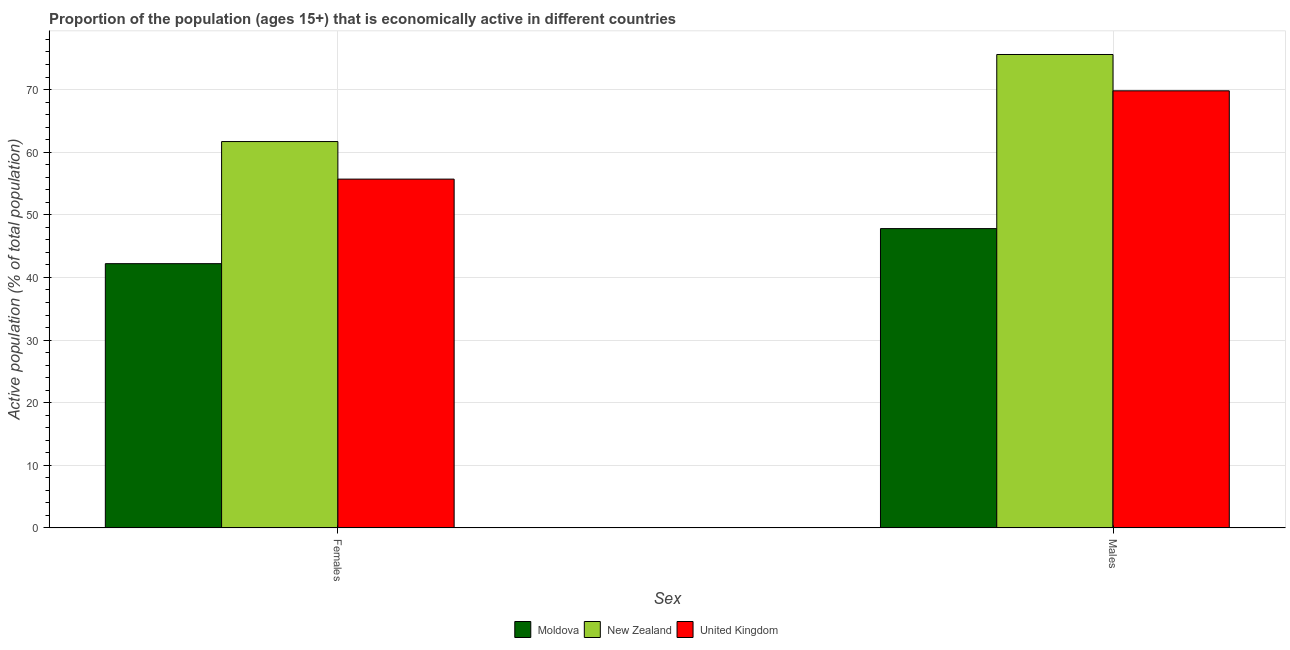How many bars are there on the 2nd tick from the right?
Make the answer very short. 3. What is the label of the 2nd group of bars from the left?
Your answer should be very brief. Males. What is the percentage of economically active male population in New Zealand?
Give a very brief answer. 75.6. Across all countries, what is the maximum percentage of economically active male population?
Provide a short and direct response. 75.6. Across all countries, what is the minimum percentage of economically active male population?
Your response must be concise. 47.8. In which country was the percentage of economically active female population maximum?
Provide a short and direct response. New Zealand. In which country was the percentage of economically active female population minimum?
Provide a short and direct response. Moldova. What is the total percentage of economically active male population in the graph?
Make the answer very short. 193.2. What is the difference between the percentage of economically active male population in New Zealand and that in Moldova?
Provide a succinct answer. 27.8. What is the difference between the percentage of economically active male population in New Zealand and the percentage of economically active female population in United Kingdom?
Keep it short and to the point. 19.9. What is the average percentage of economically active female population per country?
Offer a very short reply. 53.2. What is the difference between the percentage of economically active male population and percentage of economically active female population in New Zealand?
Your answer should be compact. 13.9. What is the ratio of the percentage of economically active female population in New Zealand to that in United Kingdom?
Provide a short and direct response. 1.11. Is the percentage of economically active female population in Moldova less than that in United Kingdom?
Your answer should be very brief. Yes. In how many countries, is the percentage of economically active male population greater than the average percentage of economically active male population taken over all countries?
Ensure brevity in your answer.  2. What does the 2nd bar from the right in Females represents?
Keep it short and to the point. New Zealand. How many countries are there in the graph?
Make the answer very short. 3. What is the difference between two consecutive major ticks on the Y-axis?
Offer a very short reply. 10. Does the graph contain any zero values?
Offer a very short reply. No. Does the graph contain grids?
Make the answer very short. Yes. How are the legend labels stacked?
Your answer should be very brief. Horizontal. What is the title of the graph?
Ensure brevity in your answer.  Proportion of the population (ages 15+) that is economically active in different countries. Does "Bolivia" appear as one of the legend labels in the graph?
Your answer should be compact. No. What is the label or title of the X-axis?
Offer a terse response. Sex. What is the label or title of the Y-axis?
Offer a terse response. Active population (% of total population). What is the Active population (% of total population) of Moldova in Females?
Keep it short and to the point. 42.2. What is the Active population (% of total population) of New Zealand in Females?
Give a very brief answer. 61.7. What is the Active population (% of total population) in United Kingdom in Females?
Ensure brevity in your answer.  55.7. What is the Active population (% of total population) in Moldova in Males?
Ensure brevity in your answer.  47.8. What is the Active population (% of total population) in New Zealand in Males?
Make the answer very short. 75.6. What is the Active population (% of total population) in United Kingdom in Males?
Your answer should be very brief. 69.8. Across all Sex, what is the maximum Active population (% of total population) in Moldova?
Give a very brief answer. 47.8. Across all Sex, what is the maximum Active population (% of total population) of New Zealand?
Ensure brevity in your answer.  75.6. Across all Sex, what is the maximum Active population (% of total population) in United Kingdom?
Offer a terse response. 69.8. Across all Sex, what is the minimum Active population (% of total population) in Moldova?
Ensure brevity in your answer.  42.2. Across all Sex, what is the minimum Active population (% of total population) of New Zealand?
Your response must be concise. 61.7. Across all Sex, what is the minimum Active population (% of total population) of United Kingdom?
Ensure brevity in your answer.  55.7. What is the total Active population (% of total population) in Moldova in the graph?
Your answer should be very brief. 90. What is the total Active population (% of total population) of New Zealand in the graph?
Your answer should be very brief. 137.3. What is the total Active population (% of total population) of United Kingdom in the graph?
Provide a short and direct response. 125.5. What is the difference between the Active population (% of total population) of United Kingdom in Females and that in Males?
Make the answer very short. -14.1. What is the difference between the Active population (% of total population) of Moldova in Females and the Active population (% of total population) of New Zealand in Males?
Your answer should be compact. -33.4. What is the difference between the Active population (% of total population) of Moldova in Females and the Active population (% of total population) of United Kingdom in Males?
Make the answer very short. -27.6. What is the average Active population (% of total population) in Moldova per Sex?
Provide a succinct answer. 45. What is the average Active population (% of total population) of New Zealand per Sex?
Offer a very short reply. 68.65. What is the average Active population (% of total population) in United Kingdom per Sex?
Make the answer very short. 62.75. What is the difference between the Active population (% of total population) in Moldova and Active population (% of total population) in New Zealand in Females?
Your answer should be very brief. -19.5. What is the difference between the Active population (% of total population) in Moldova and Active population (% of total population) in United Kingdom in Females?
Offer a terse response. -13.5. What is the difference between the Active population (% of total population) in New Zealand and Active population (% of total population) in United Kingdom in Females?
Your answer should be very brief. 6. What is the difference between the Active population (% of total population) of Moldova and Active population (% of total population) of New Zealand in Males?
Provide a succinct answer. -27.8. What is the difference between the Active population (% of total population) of Moldova and Active population (% of total population) of United Kingdom in Males?
Give a very brief answer. -22. What is the difference between the Active population (% of total population) of New Zealand and Active population (% of total population) of United Kingdom in Males?
Your response must be concise. 5.8. What is the ratio of the Active population (% of total population) in Moldova in Females to that in Males?
Provide a short and direct response. 0.88. What is the ratio of the Active population (% of total population) in New Zealand in Females to that in Males?
Your answer should be compact. 0.82. What is the ratio of the Active population (% of total population) of United Kingdom in Females to that in Males?
Your response must be concise. 0.8. What is the difference between the highest and the second highest Active population (% of total population) in Moldova?
Give a very brief answer. 5.6. What is the difference between the highest and the lowest Active population (% of total population) in Moldova?
Provide a short and direct response. 5.6. What is the difference between the highest and the lowest Active population (% of total population) in New Zealand?
Keep it short and to the point. 13.9. What is the difference between the highest and the lowest Active population (% of total population) of United Kingdom?
Give a very brief answer. 14.1. 